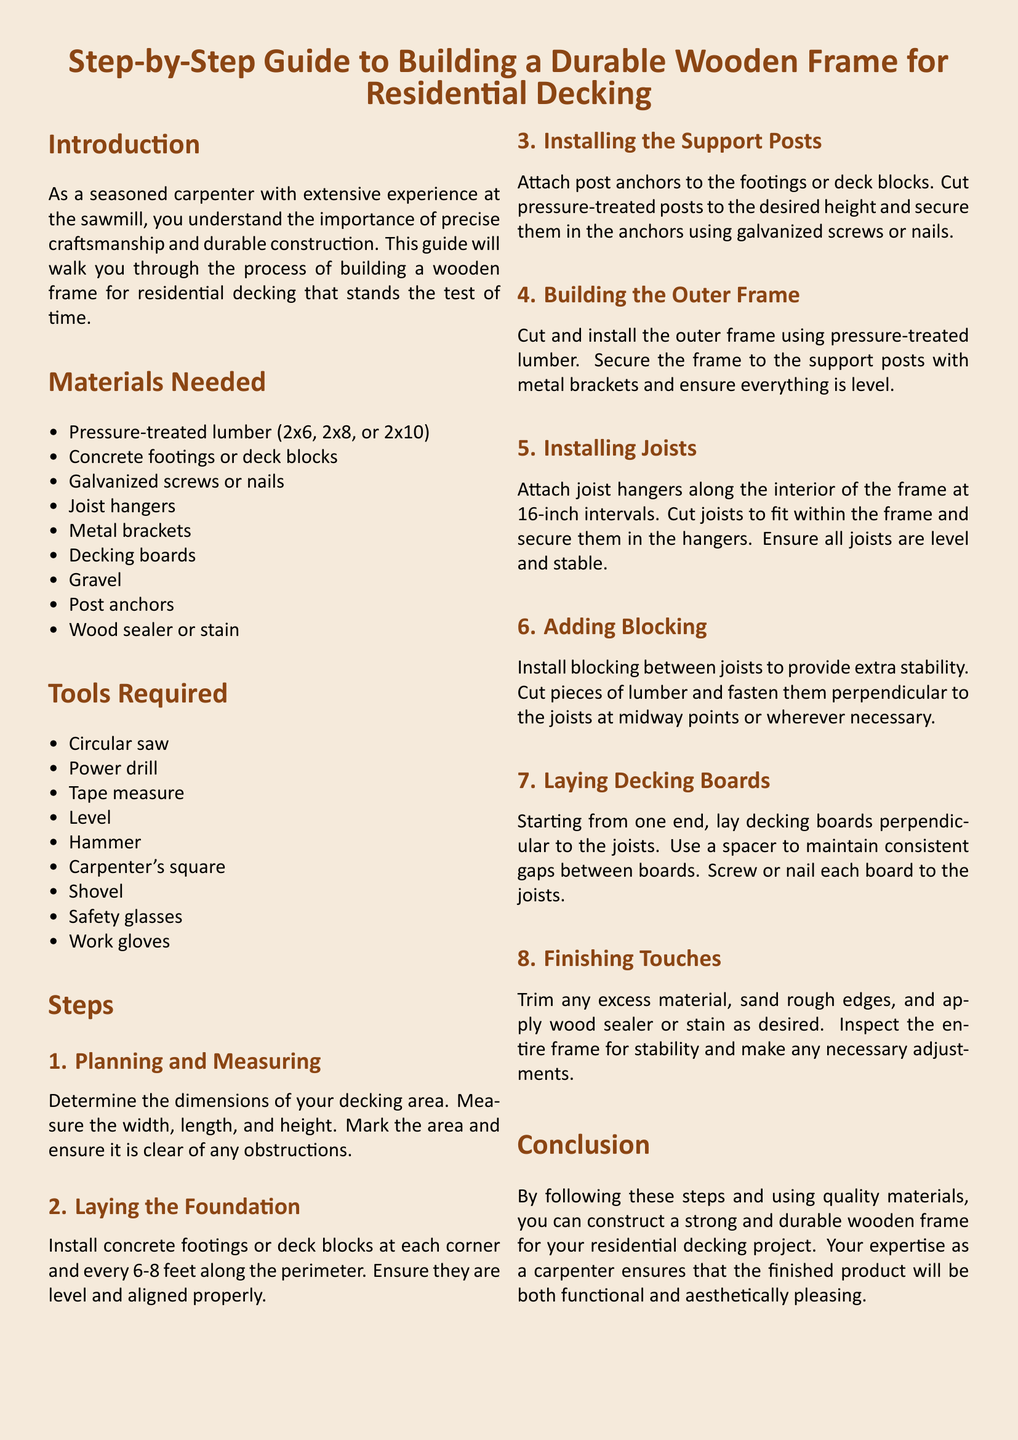What type of lumber is recommended? The document specifies pressure-treated lumber (2x6, 2x8, or 2x10) for building the frame.
Answer: Pressure-treated lumber (2x6, 2x8, or 2x10) How far apart should concrete footings be installed? The instructions indicate that concrete footings or deck blocks should be placed at every 6-8 feet along the perimeter.
Answer: Every 6-8 feet What is the first step in the assembly process? The guide states that the first step is to plan and measure the dimensions of the decking area.
Answer: Planning and Measuring How many tools are listed as required? The document lists nine tools that are necessary for the assembly process.
Answer: Nine What is used to secure joists in the frame? Joist hangers are mentioned as the means to attach and secure the joists within the frame.
Answer: Joist hangers What is the purpose of blocking? The guide explains that blocking is installed between joists to provide extra stability.
Answer: Extra stability What should be done after laying decking boards? The document advises trimming excess material, sanding rough edges, and applying wood sealer or stain as finishing touches.
Answer: Finishing Touches How many intervals should joists be attached? Joists are to be attached at 16-inch intervals as specified in the assembly instructions.
Answer: 16-inch intervals 